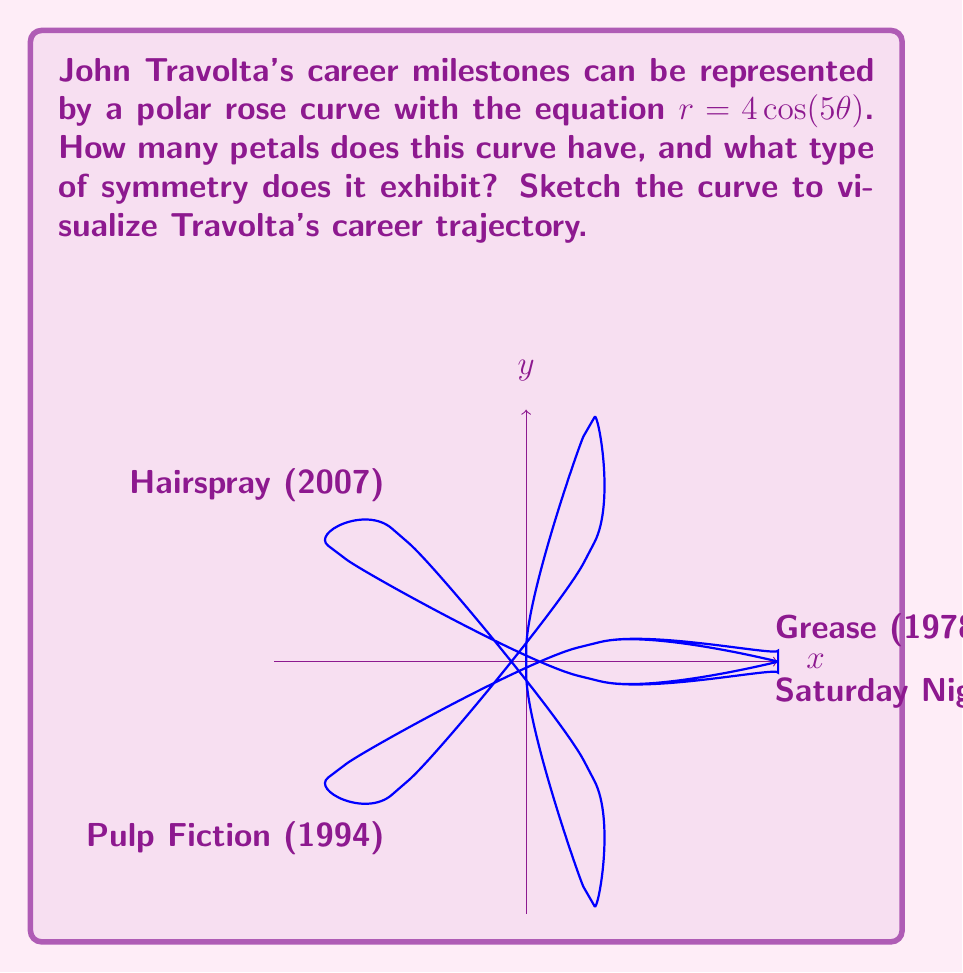What is the answer to this math problem? To analyze the symmetry and determine the number of petals in the polar rose curve representing John Travolta's career milestones, we follow these steps:

1) The general equation for a polar rose is $r = a \cos(n\theta)$ or $r = a \sin(n\theta)$, where $n$ is an integer.

2) In this case, we have $r = 4\cos(5\theta)$, so $a = 4$ and $n = 5$.

3) The number of petals in a polar rose depends on $n$:
   - If $n$ is odd, the number of petals is $n$.
   - If $n$ is even, the number of petals is $2n$.

4) Here, $n = 5$, which is odd. Therefore, the curve has 5 petals.

5) Regarding symmetry:
   - The curve has rotational symmetry of order 5, meaning it looks the same after rotating by $\frac{2\pi}{5}$ radians or 72°.
   - It also has reflection symmetry about 5 lines: the x-axis and lines at angles of $\frac{\pi}{5}$, $\frac{2\pi}{5}$, $\frac{3\pi}{5}$, and $\frac{4\pi}{5}$ radians from the x-axis.

6) The curve completes one full rotation when $\theta$ goes from 0 to $\frac{2\pi}{5}$.

7) The maximum radius occurs when $\cos(5\theta) = 1$, i.e., when $5\theta = 0, 2\pi, 4\pi, ...$, giving the peak of each petal.

8) The curve passes through the origin when $\cos(5\theta) = 0$, i.e., when $5\theta = \frac{\pi}{2}, \frac{3\pi}{2}, \frac{5\pi}{2}, ...$, which are the points between petals.

The sketch provided in the question visually demonstrates these properties, with each petal potentially representing a significant phase or milestone in John Travolta's career.
Answer: 5 petals; 5-fold rotational and 5-line reflection symmetry. 